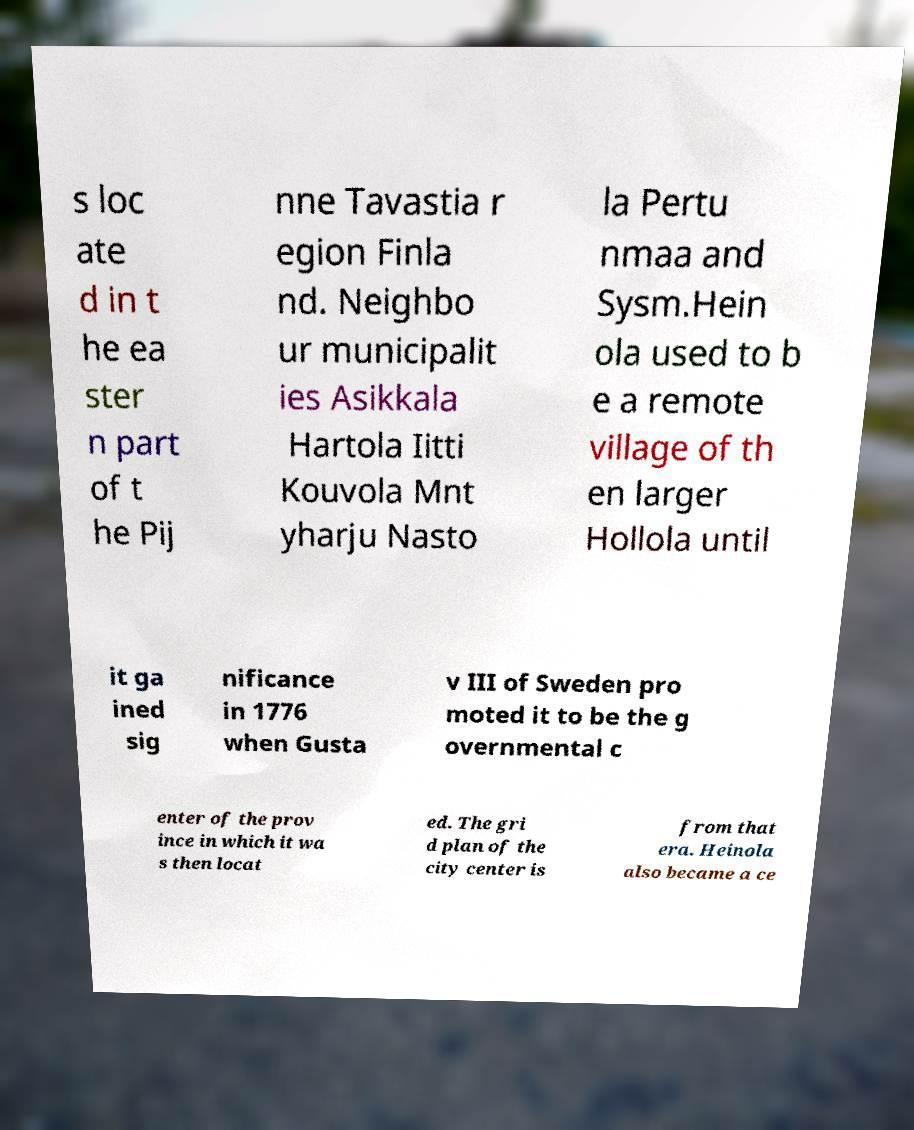Can you read and provide the text displayed in the image?This photo seems to have some interesting text. Can you extract and type it out for me? s loc ate d in t he ea ster n part of t he Pij nne Tavastia r egion Finla nd. Neighbo ur municipalit ies Asikkala Hartola Iitti Kouvola Mnt yharju Nasto la Pertu nmaa and Sysm.Hein ola used to b e a remote village of th en larger Hollola until it ga ined sig nificance in 1776 when Gusta v III of Sweden pro moted it to be the g overnmental c enter of the prov ince in which it wa s then locat ed. The gri d plan of the city center is from that era. Heinola also became a ce 